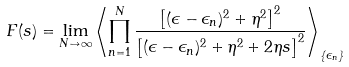Convert formula to latex. <formula><loc_0><loc_0><loc_500><loc_500>F ( s ) = \lim _ { N \to \infty } \left \langle \prod _ { n = 1 } ^ { N } \frac { \left [ ( \epsilon - \epsilon _ { n } ) ^ { 2 } + \eta ^ { 2 } \right ] ^ { 2 } } { \left [ ( \epsilon - \epsilon _ { n } ) ^ { 2 } + \eta ^ { 2 } + 2 \eta s \right ] ^ { 2 } } \right \rangle _ { \{ \epsilon _ { n } \} }</formula> 